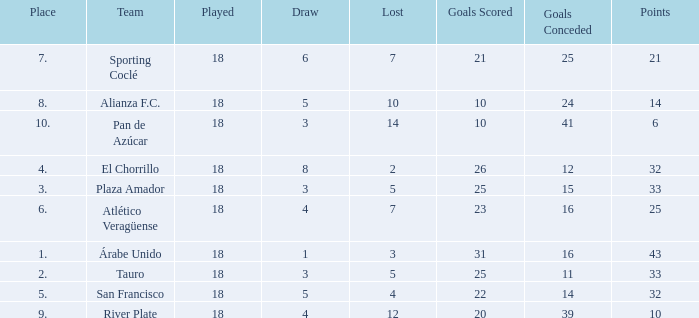How many points did the team have that conceded 41 goals and finish in a place larger than 10? 0.0. 